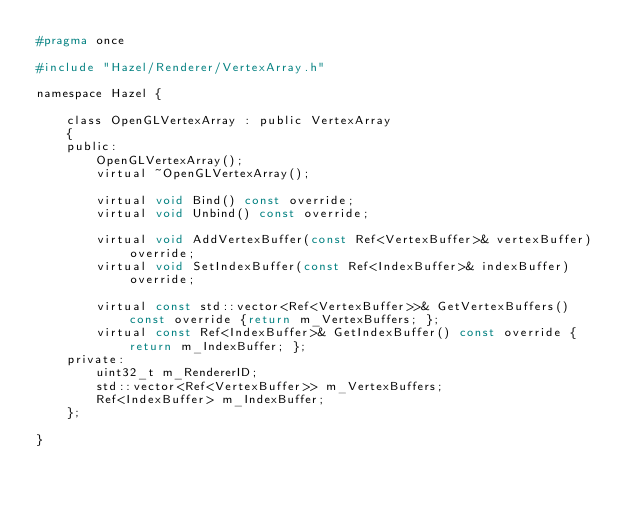Convert code to text. <code><loc_0><loc_0><loc_500><loc_500><_C_>#pragma once

#include "Hazel/Renderer/VertexArray.h"

namespace Hazel {

	class OpenGLVertexArray : public VertexArray
	{
	public:
		OpenGLVertexArray();
		virtual ~OpenGLVertexArray();

		virtual void Bind() const override;
		virtual void Unbind() const override;

		virtual void AddVertexBuffer(const Ref<VertexBuffer>& vertexBuffer) override;
		virtual void SetIndexBuffer(const Ref<IndexBuffer>& indexBuffer) override;

		virtual const std::vector<Ref<VertexBuffer>>& GetVertexBuffers() const override {return m_VertexBuffers; };
		virtual const Ref<IndexBuffer>& GetIndexBuffer() const override { return m_IndexBuffer; };
	private:
		uint32_t m_RendererID;
		std::vector<Ref<VertexBuffer>> m_VertexBuffers;
		Ref<IndexBuffer> m_IndexBuffer;
	};

}</code> 